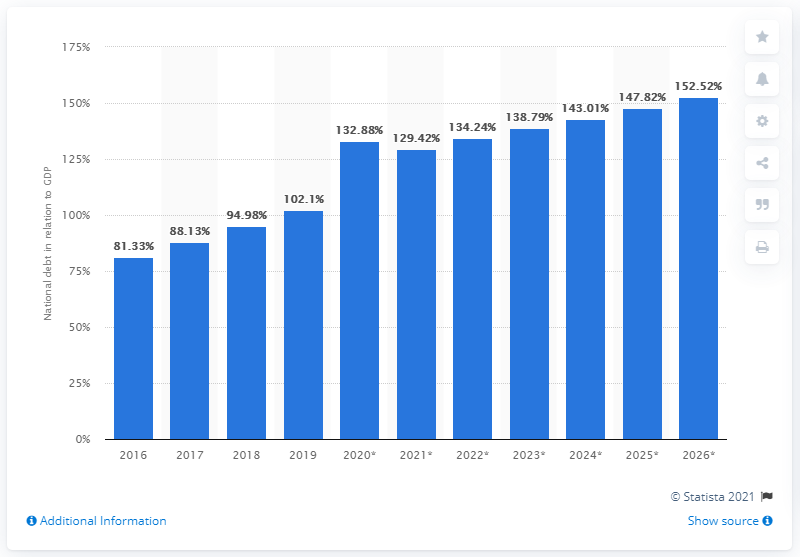Draw attention to some important aspects in this diagram. In 2019, Bahrain's national debt accounted for approximately 102.1% of the country's GDP, according to recent data. 